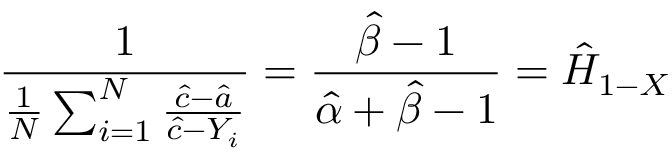Convert formula to latex. <formula><loc_0><loc_0><loc_500><loc_500>{ \frac { 1 } { { \frac { 1 } { N } } \sum _ { i = 1 } ^ { N } { \frac { { \hat { c } } - { \hat { a } } } { { \hat { c } } - Y _ { i } } } } } = { \frac { { \hat { \beta } } - 1 } { { \hat { \alpha } } + { \hat { \beta } } - 1 } } = { \hat { H } } _ { 1 - X }</formula> 